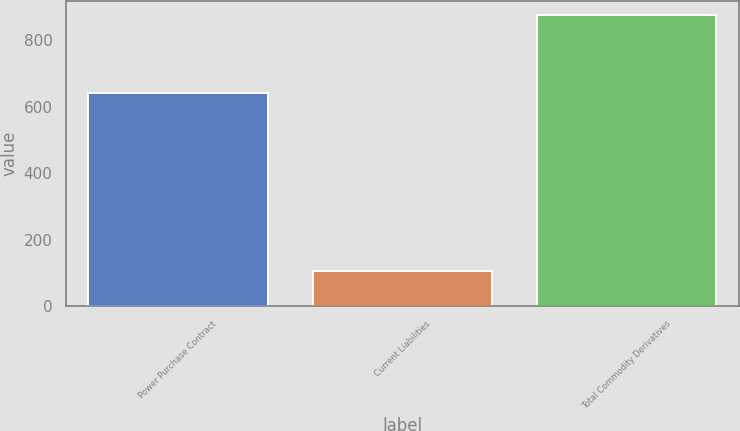Convert chart. <chart><loc_0><loc_0><loc_500><loc_500><bar_chart><fcel>Power Purchase Contract<fcel>Current Liabilities<fcel>Total Commodity Derivatives<nl><fcel>643<fcel>106<fcel>876<nl></chart> 